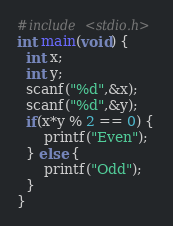<code> <loc_0><loc_0><loc_500><loc_500><_C_>#include <stdio.h>
int main(void) {
  int x;
  int y;
  scanf("%d",&x);
  scanf("%d",&y);
  if(x*y % 2 == 0) {
      printf("Even");
  } else {
      printf("Odd");
  }
}</code> 